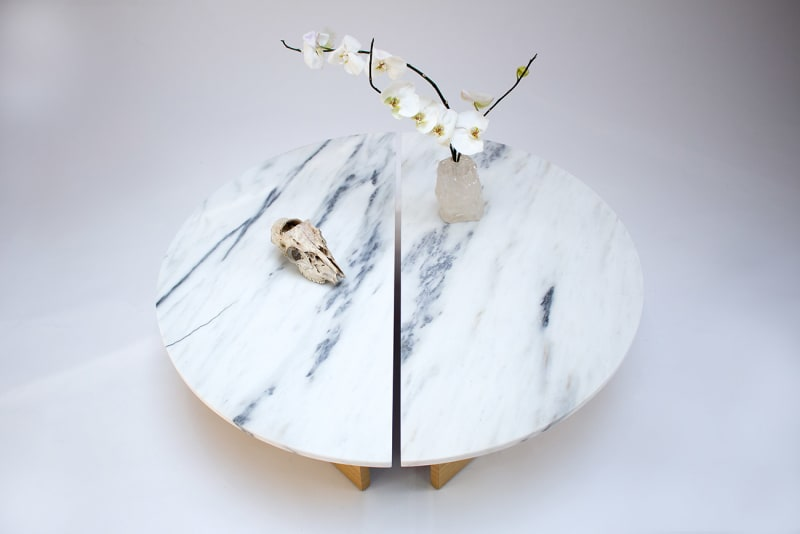What might be the significance of choosing these particular elements for the table's decor? The marble and crystal are known for their durability and timelessness, often associated with sophistication and longevity. Choosing an orchid and bird skull alongside these items introduces organic elements that are more transient and susceptible to the passage of time. This selection suggests a deliberate meditation on contrast and balance—between the ephemeral and the eternal, as well as the aesthetic convergence of natural forms and crafted beauty. 